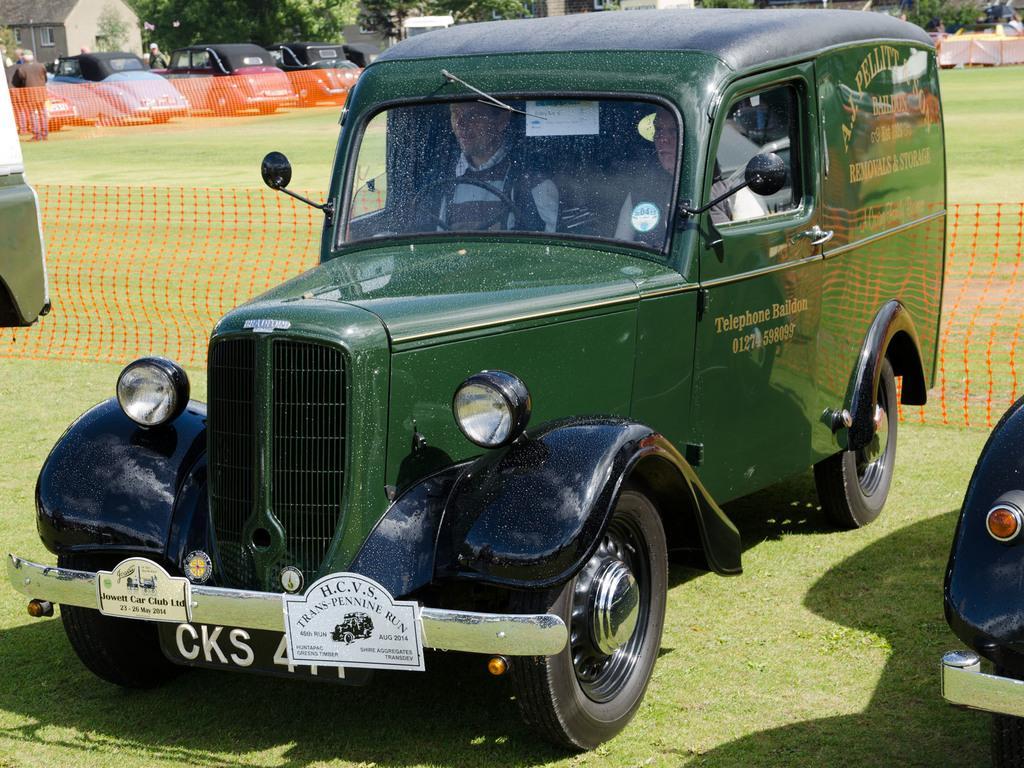In one or two sentences, can you explain what this image depicts? In this image we can see motor vehicles on the ground. In the background we can see buildings and trees. 